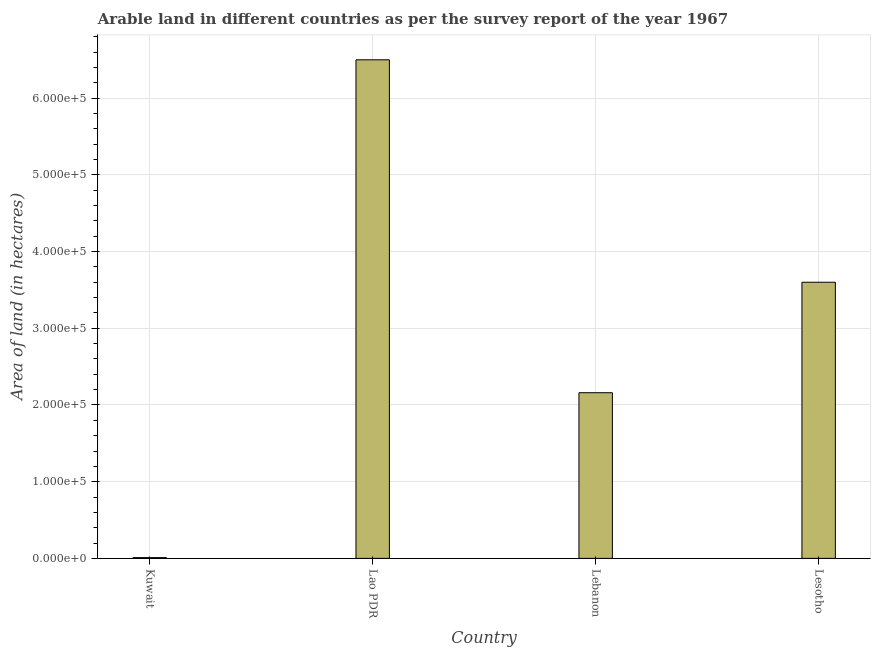Does the graph contain grids?
Make the answer very short. Yes. What is the title of the graph?
Ensure brevity in your answer.  Arable land in different countries as per the survey report of the year 1967. What is the label or title of the X-axis?
Make the answer very short. Country. What is the label or title of the Y-axis?
Give a very brief answer. Area of land (in hectares). What is the area of land in Lebanon?
Offer a very short reply. 2.16e+05. Across all countries, what is the maximum area of land?
Your answer should be compact. 6.50e+05. Across all countries, what is the minimum area of land?
Your response must be concise. 1000. In which country was the area of land maximum?
Keep it short and to the point. Lao PDR. In which country was the area of land minimum?
Make the answer very short. Kuwait. What is the sum of the area of land?
Provide a short and direct response. 1.23e+06. What is the difference between the area of land in Kuwait and Lesotho?
Your answer should be very brief. -3.59e+05. What is the average area of land per country?
Keep it short and to the point. 3.07e+05. What is the median area of land?
Make the answer very short. 2.88e+05. What is the ratio of the area of land in Kuwait to that in Lesotho?
Your answer should be compact. 0. Is the area of land in Kuwait less than that in Lebanon?
Make the answer very short. Yes. Is the difference between the area of land in Lao PDR and Lebanon greater than the difference between any two countries?
Provide a short and direct response. No. Is the sum of the area of land in Kuwait and Lao PDR greater than the maximum area of land across all countries?
Offer a terse response. Yes. What is the difference between the highest and the lowest area of land?
Provide a short and direct response. 6.49e+05. In how many countries, is the area of land greater than the average area of land taken over all countries?
Offer a terse response. 2. How many bars are there?
Make the answer very short. 4. How many countries are there in the graph?
Your answer should be very brief. 4. What is the Area of land (in hectares) of Kuwait?
Provide a short and direct response. 1000. What is the Area of land (in hectares) in Lao PDR?
Make the answer very short. 6.50e+05. What is the Area of land (in hectares) of Lebanon?
Your answer should be compact. 2.16e+05. What is the difference between the Area of land (in hectares) in Kuwait and Lao PDR?
Offer a very short reply. -6.49e+05. What is the difference between the Area of land (in hectares) in Kuwait and Lebanon?
Ensure brevity in your answer.  -2.15e+05. What is the difference between the Area of land (in hectares) in Kuwait and Lesotho?
Offer a very short reply. -3.59e+05. What is the difference between the Area of land (in hectares) in Lao PDR and Lebanon?
Your answer should be very brief. 4.34e+05. What is the difference between the Area of land (in hectares) in Lao PDR and Lesotho?
Offer a terse response. 2.90e+05. What is the difference between the Area of land (in hectares) in Lebanon and Lesotho?
Provide a short and direct response. -1.44e+05. What is the ratio of the Area of land (in hectares) in Kuwait to that in Lao PDR?
Make the answer very short. 0. What is the ratio of the Area of land (in hectares) in Kuwait to that in Lebanon?
Your answer should be very brief. 0.01. What is the ratio of the Area of land (in hectares) in Kuwait to that in Lesotho?
Provide a succinct answer. 0. What is the ratio of the Area of land (in hectares) in Lao PDR to that in Lebanon?
Keep it short and to the point. 3.01. What is the ratio of the Area of land (in hectares) in Lao PDR to that in Lesotho?
Your answer should be very brief. 1.81. What is the ratio of the Area of land (in hectares) in Lebanon to that in Lesotho?
Give a very brief answer. 0.6. 